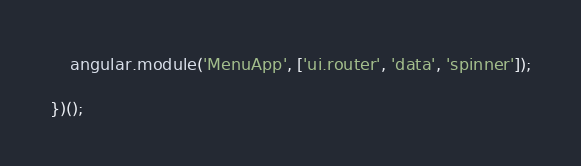Convert code to text. <code><loc_0><loc_0><loc_500><loc_500><_JavaScript_>	angular.module('MenuApp', ['ui.router', 'data', 'spinner']);

})();</code> 